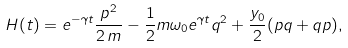Convert formula to latex. <formula><loc_0><loc_0><loc_500><loc_500>H ( t ) = e ^ { - \gamma t } \frac { p ^ { 2 } } { 2 \, m } - \frac { 1 } { 2 } m \omega _ { 0 } e ^ { \gamma t } q ^ { 2 } + \frac { y _ { 0 } } { 2 } ( p q + q p ) ,</formula> 